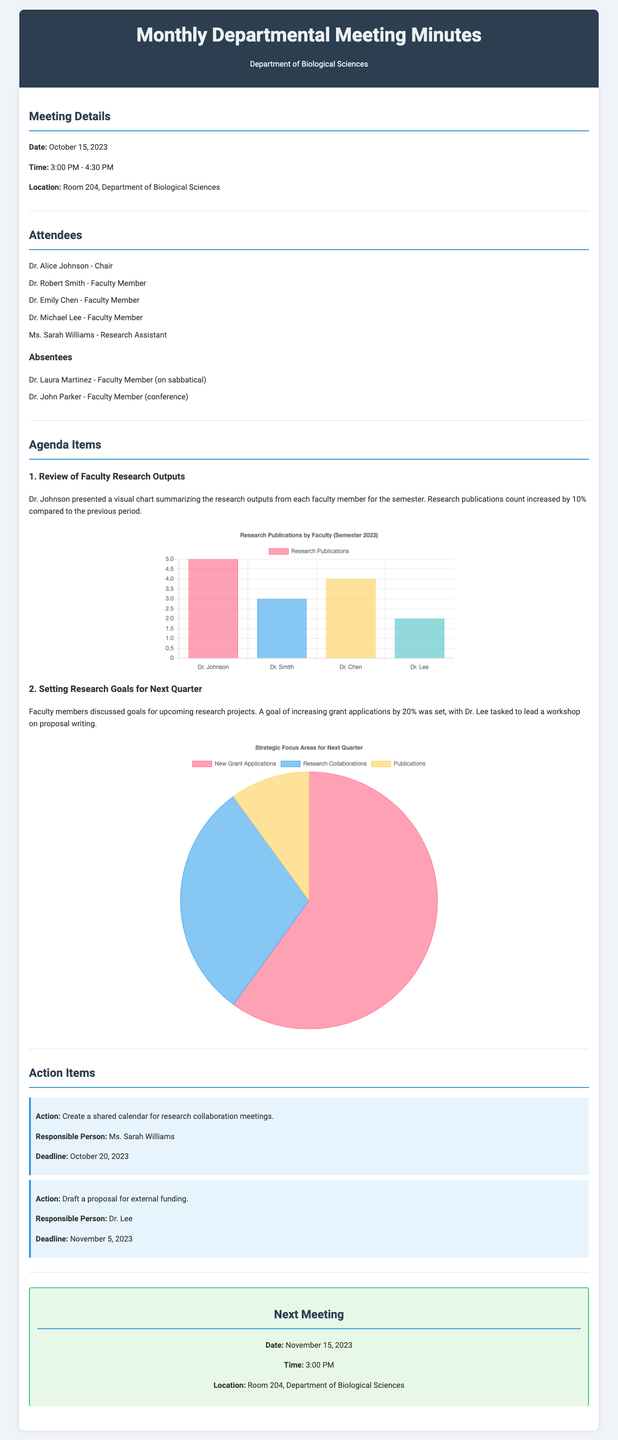What is the date of the meeting? The meeting date is explicitly mentioned at the beginning of the document.
Answer: October 15, 2023 Who presented the research outputs? The document clearly states that Dr. Johnson was responsible for presenting the research outputs during the meeting.
Answer: Dr. Johnson What is the increase in research publications count? This increase is noted in the meeting minutes as a percentage change compared to the previous period.
Answer: 10% How many faculty members attended the meeting? The attendees section lists the faculty members present, allowing us to count them.
Answer: 4 What is the goal set for grant applications? Goals for the upcoming quarter are discussed, particularly focusing on the grant applications.
Answer: 20% What are the three strategic focus areas for next quarter? These areas are summarized in the pie chart, representing the planned focus for faculty efforts.
Answer: New Grant Applications, Research Collaborations, Publications Who is responsible for creating the shared calendar? The action items specify who is accountable for each task, including the shared calendar.
Answer: Ms. Sarah Williams When is the next meeting scheduled? This information is outlined at the end of the document and indicates future meeting details.
Answer: November 15, 2023 